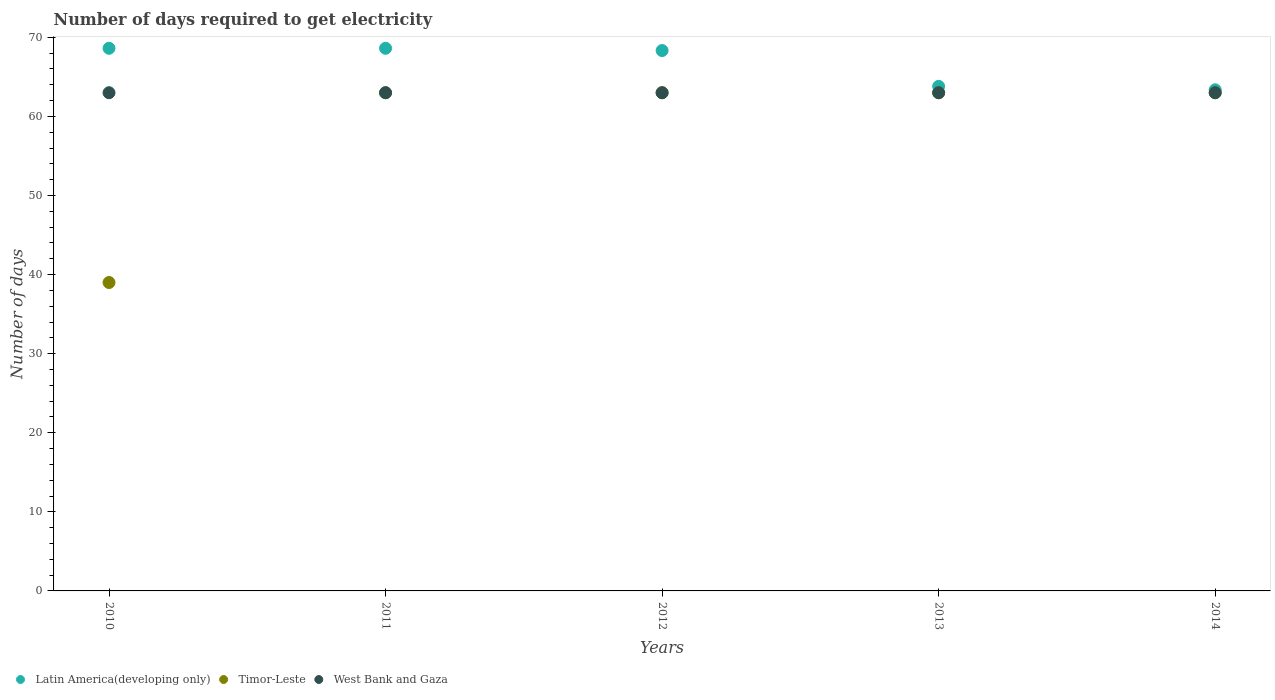What is the number of days required to get electricity in in Latin America(developing only) in 2010?
Your answer should be compact. 68.62. Across all years, what is the maximum number of days required to get electricity in in Timor-Leste?
Your response must be concise. 63. Across all years, what is the minimum number of days required to get electricity in in West Bank and Gaza?
Provide a short and direct response. 63. In which year was the number of days required to get electricity in in Timor-Leste maximum?
Offer a very short reply. 2011. In which year was the number of days required to get electricity in in Timor-Leste minimum?
Provide a succinct answer. 2010. What is the total number of days required to get electricity in in Timor-Leste in the graph?
Make the answer very short. 291. What is the difference between the number of days required to get electricity in in West Bank and Gaza in 2010 and that in 2014?
Your answer should be compact. 0. In the year 2013, what is the difference between the number of days required to get electricity in in West Bank and Gaza and number of days required to get electricity in in Timor-Leste?
Offer a terse response. 0. In how many years, is the number of days required to get electricity in in West Bank and Gaza greater than 48 days?
Provide a short and direct response. 5. What is the difference between the highest and the lowest number of days required to get electricity in in West Bank and Gaza?
Offer a terse response. 0. In how many years, is the number of days required to get electricity in in Timor-Leste greater than the average number of days required to get electricity in in Timor-Leste taken over all years?
Provide a short and direct response. 4. Is the sum of the number of days required to get electricity in in Timor-Leste in 2013 and 2014 greater than the maximum number of days required to get electricity in in Latin America(developing only) across all years?
Your answer should be compact. Yes. Does the number of days required to get electricity in in West Bank and Gaza monotonically increase over the years?
Make the answer very short. No. Is the number of days required to get electricity in in West Bank and Gaza strictly less than the number of days required to get electricity in in Latin America(developing only) over the years?
Provide a succinct answer. Yes. How many dotlines are there?
Keep it short and to the point. 3. What is the difference between two consecutive major ticks on the Y-axis?
Keep it short and to the point. 10. Does the graph contain grids?
Give a very brief answer. No. How many legend labels are there?
Offer a terse response. 3. What is the title of the graph?
Your answer should be very brief. Number of days required to get electricity. Does "Pacific island small states" appear as one of the legend labels in the graph?
Offer a very short reply. No. What is the label or title of the Y-axis?
Your answer should be compact. Number of days. What is the Number of days in Latin America(developing only) in 2010?
Offer a very short reply. 68.62. What is the Number of days in Timor-Leste in 2010?
Keep it short and to the point. 39. What is the Number of days of West Bank and Gaza in 2010?
Ensure brevity in your answer.  63. What is the Number of days in Latin America(developing only) in 2011?
Offer a very short reply. 68.62. What is the Number of days of Timor-Leste in 2011?
Offer a very short reply. 63. What is the Number of days in West Bank and Gaza in 2011?
Give a very brief answer. 63. What is the Number of days in Latin America(developing only) in 2012?
Your answer should be very brief. 68.33. What is the Number of days in Timor-Leste in 2012?
Offer a very short reply. 63. What is the Number of days in West Bank and Gaza in 2012?
Provide a short and direct response. 63. What is the Number of days in Latin America(developing only) in 2013?
Make the answer very short. 63.8. What is the Number of days in Timor-Leste in 2013?
Your answer should be very brief. 63. What is the Number of days in Latin America(developing only) in 2014?
Provide a succinct answer. 63.37. Across all years, what is the maximum Number of days in Latin America(developing only)?
Your response must be concise. 68.62. Across all years, what is the maximum Number of days of Timor-Leste?
Your answer should be compact. 63. Across all years, what is the minimum Number of days of Latin America(developing only)?
Ensure brevity in your answer.  63.37. Across all years, what is the minimum Number of days in Timor-Leste?
Offer a very short reply. 39. What is the total Number of days of Latin America(developing only) in the graph?
Provide a short and direct response. 332.75. What is the total Number of days of Timor-Leste in the graph?
Provide a short and direct response. 291. What is the total Number of days in West Bank and Gaza in the graph?
Your answer should be compact. 315. What is the difference between the Number of days of Latin America(developing only) in 2010 and that in 2011?
Give a very brief answer. 0. What is the difference between the Number of days in West Bank and Gaza in 2010 and that in 2011?
Make the answer very short. 0. What is the difference between the Number of days of Latin America(developing only) in 2010 and that in 2012?
Your answer should be very brief. 0.29. What is the difference between the Number of days of Timor-Leste in 2010 and that in 2012?
Your response must be concise. -24. What is the difference between the Number of days in West Bank and Gaza in 2010 and that in 2012?
Offer a very short reply. 0. What is the difference between the Number of days of Latin America(developing only) in 2010 and that in 2013?
Your answer should be very brief. 4.81. What is the difference between the Number of days of Latin America(developing only) in 2010 and that in 2014?
Give a very brief answer. 5.25. What is the difference between the Number of days in Latin America(developing only) in 2011 and that in 2012?
Ensure brevity in your answer.  0.29. What is the difference between the Number of days in Timor-Leste in 2011 and that in 2012?
Keep it short and to the point. 0. What is the difference between the Number of days of Latin America(developing only) in 2011 and that in 2013?
Your answer should be compact. 4.81. What is the difference between the Number of days in West Bank and Gaza in 2011 and that in 2013?
Your answer should be compact. 0. What is the difference between the Number of days of Latin America(developing only) in 2011 and that in 2014?
Give a very brief answer. 5.25. What is the difference between the Number of days of Timor-Leste in 2011 and that in 2014?
Ensure brevity in your answer.  0. What is the difference between the Number of days in Latin America(developing only) in 2012 and that in 2013?
Your answer should be very brief. 4.53. What is the difference between the Number of days of Timor-Leste in 2012 and that in 2013?
Your answer should be compact. 0. What is the difference between the Number of days in West Bank and Gaza in 2012 and that in 2013?
Offer a very short reply. 0. What is the difference between the Number of days of Latin America(developing only) in 2012 and that in 2014?
Give a very brief answer. 4.96. What is the difference between the Number of days in Timor-Leste in 2012 and that in 2014?
Ensure brevity in your answer.  0. What is the difference between the Number of days in West Bank and Gaza in 2012 and that in 2014?
Your answer should be very brief. 0. What is the difference between the Number of days of Latin America(developing only) in 2013 and that in 2014?
Offer a very short reply. 0.43. What is the difference between the Number of days in Timor-Leste in 2013 and that in 2014?
Give a very brief answer. 0. What is the difference between the Number of days in West Bank and Gaza in 2013 and that in 2014?
Provide a short and direct response. 0. What is the difference between the Number of days in Latin America(developing only) in 2010 and the Number of days in Timor-Leste in 2011?
Provide a succinct answer. 5.62. What is the difference between the Number of days of Latin America(developing only) in 2010 and the Number of days of West Bank and Gaza in 2011?
Offer a very short reply. 5.62. What is the difference between the Number of days of Timor-Leste in 2010 and the Number of days of West Bank and Gaza in 2011?
Offer a terse response. -24. What is the difference between the Number of days of Latin America(developing only) in 2010 and the Number of days of Timor-Leste in 2012?
Provide a short and direct response. 5.62. What is the difference between the Number of days of Latin America(developing only) in 2010 and the Number of days of West Bank and Gaza in 2012?
Keep it short and to the point. 5.62. What is the difference between the Number of days of Latin America(developing only) in 2010 and the Number of days of Timor-Leste in 2013?
Your response must be concise. 5.62. What is the difference between the Number of days of Latin America(developing only) in 2010 and the Number of days of West Bank and Gaza in 2013?
Your answer should be very brief. 5.62. What is the difference between the Number of days in Latin America(developing only) in 2010 and the Number of days in Timor-Leste in 2014?
Provide a short and direct response. 5.62. What is the difference between the Number of days of Latin America(developing only) in 2010 and the Number of days of West Bank and Gaza in 2014?
Give a very brief answer. 5.62. What is the difference between the Number of days in Latin America(developing only) in 2011 and the Number of days in Timor-Leste in 2012?
Make the answer very short. 5.62. What is the difference between the Number of days of Latin America(developing only) in 2011 and the Number of days of West Bank and Gaza in 2012?
Provide a short and direct response. 5.62. What is the difference between the Number of days of Timor-Leste in 2011 and the Number of days of West Bank and Gaza in 2012?
Your response must be concise. 0. What is the difference between the Number of days of Latin America(developing only) in 2011 and the Number of days of Timor-Leste in 2013?
Offer a terse response. 5.62. What is the difference between the Number of days in Latin America(developing only) in 2011 and the Number of days in West Bank and Gaza in 2013?
Provide a succinct answer. 5.62. What is the difference between the Number of days of Latin America(developing only) in 2011 and the Number of days of Timor-Leste in 2014?
Your response must be concise. 5.62. What is the difference between the Number of days in Latin America(developing only) in 2011 and the Number of days in West Bank and Gaza in 2014?
Keep it short and to the point. 5.62. What is the difference between the Number of days of Latin America(developing only) in 2012 and the Number of days of Timor-Leste in 2013?
Your answer should be very brief. 5.33. What is the difference between the Number of days of Latin America(developing only) in 2012 and the Number of days of West Bank and Gaza in 2013?
Offer a very short reply. 5.33. What is the difference between the Number of days in Timor-Leste in 2012 and the Number of days in West Bank and Gaza in 2013?
Your answer should be compact. 0. What is the difference between the Number of days in Latin America(developing only) in 2012 and the Number of days in Timor-Leste in 2014?
Your response must be concise. 5.33. What is the difference between the Number of days of Latin America(developing only) in 2012 and the Number of days of West Bank and Gaza in 2014?
Give a very brief answer. 5.33. What is the difference between the Number of days of Latin America(developing only) in 2013 and the Number of days of Timor-Leste in 2014?
Provide a short and direct response. 0.8. What is the difference between the Number of days of Latin America(developing only) in 2013 and the Number of days of West Bank and Gaza in 2014?
Your response must be concise. 0.8. What is the average Number of days of Latin America(developing only) per year?
Provide a succinct answer. 66.55. What is the average Number of days in Timor-Leste per year?
Offer a very short reply. 58.2. In the year 2010, what is the difference between the Number of days in Latin America(developing only) and Number of days in Timor-Leste?
Your response must be concise. 29.62. In the year 2010, what is the difference between the Number of days of Latin America(developing only) and Number of days of West Bank and Gaza?
Your response must be concise. 5.62. In the year 2011, what is the difference between the Number of days in Latin America(developing only) and Number of days in Timor-Leste?
Ensure brevity in your answer.  5.62. In the year 2011, what is the difference between the Number of days of Latin America(developing only) and Number of days of West Bank and Gaza?
Your answer should be very brief. 5.62. In the year 2011, what is the difference between the Number of days of Timor-Leste and Number of days of West Bank and Gaza?
Offer a very short reply. 0. In the year 2012, what is the difference between the Number of days of Latin America(developing only) and Number of days of Timor-Leste?
Make the answer very short. 5.33. In the year 2012, what is the difference between the Number of days of Latin America(developing only) and Number of days of West Bank and Gaza?
Ensure brevity in your answer.  5.33. In the year 2012, what is the difference between the Number of days in Timor-Leste and Number of days in West Bank and Gaza?
Give a very brief answer. 0. In the year 2013, what is the difference between the Number of days in Latin America(developing only) and Number of days in Timor-Leste?
Make the answer very short. 0.8. In the year 2013, what is the difference between the Number of days of Latin America(developing only) and Number of days of West Bank and Gaza?
Give a very brief answer. 0.8. In the year 2014, what is the difference between the Number of days of Latin America(developing only) and Number of days of Timor-Leste?
Your response must be concise. 0.37. In the year 2014, what is the difference between the Number of days of Latin America(developing only) and Number of days of West Bank and Gaza?
Give a very brief answer. 0.37. What is the ratio of the Number of days in Latin America(developing only) in 2010 to that in 2011?
Your answer should be compact. 1. What is the ratio of the Number of days of Timor-Leste in 2010 to that in 2011?
Keep it short and to the point. 0.62. What is the ratio of the Number of days of West Bank and Gaza in 2010 to that in 2011?
Make the answer very short. 1. What is the ratio of the Number of days of Latin America(developing only) in 2010 to that in 2012?
Offer a very short reply. 1. What is the ratio of the Number of days in Timor-Leste in 2010 to that in 2012?
Offer a terse response. 0.62. What is the ratio of the Number of days in West Bank and Gaza in 2010 to that in 2012?
Offer a terse response. 1. What is the ratio of the Number of days in Latin America(developing only) in 2010 to that in 2013?
Offer a terse response. 1.08. What is the ratio of the Number of days in Timor-Leste in 2010 to that in 2013?
Make the answer very short. 0.62. What is the ratio of the Number of days of Latin America(developing only) in 2010 to that in 2014?
Give a very brief answer. 1.08. What is the ratio of the Number of days in Timor-Leste in 2010 to that in 2014?
Ensure brevity in your answer.  0.62. What is the ratio of the Number of days in Latin America(developing only) in 2011 to that in 2012?
Give a very brief answer. 1. What is the ratio of the Number of days in Timor-Leste in 2011 to that in 2012?
Give a very brief answer. 1. What is the ratio of the Number of days of West Bank and Gaza in 2011 to that in 2012?
Offer a very short reply. 1. What is the ratio of the Number of days in Latin America(developing only) in 2011 to that in 2013?
Make the answer very short. 1.08. What is the ratio of the Number of days of Timor-Leste in 2011 to that in 2013?
Your answer should be compact. 1. What is the ratio of the Number of days in Latin America(developing only) in 2011 to that in 2014?
Provide a short and direct response. 1.08. What is the ratio of the Number of days of West Bank and Gaza in 2011 to that in 2014?
Offer a very short reply. 1. What is the ratio of the Number of days in Latin America(developing only) in 2012 to that in 2013?
Your response must be concise. 1.07. What is the ratio of the Number of days of West Bank and Gaza in 2012 to that in 2013?
Provide a short and direct response. 1. What is the ratio of the Number of days of Latin America(developing only) in 2012 to that in 2014?
Provide a succinct answer. 1.08. What is the ratio of the Number of days of Timor-Leste in 2012 to that in 2014?
Give a very brief answer. 1. What is the ratio of the Number of days in West Bank and Gaza in 2012 to that in 2014?
Provide a succinct answer. 1. What is the ratio of the Number of days of Latin America(developing only) in 2013 to that in 2014?
Your answer should be compact. 1.01. What is the ratio of the Number of days in Timor-Leste in 2013 to that in 2014?
Keep it short and to the point. 1. What is the difference between the highest and the second highest Number of days of West Bank and Gaza?
Make the answer very short. 0. What is the difference between the highest and the lowest Number of days of Latin America(developing only)?
Offer a very short reply. 5.25. 